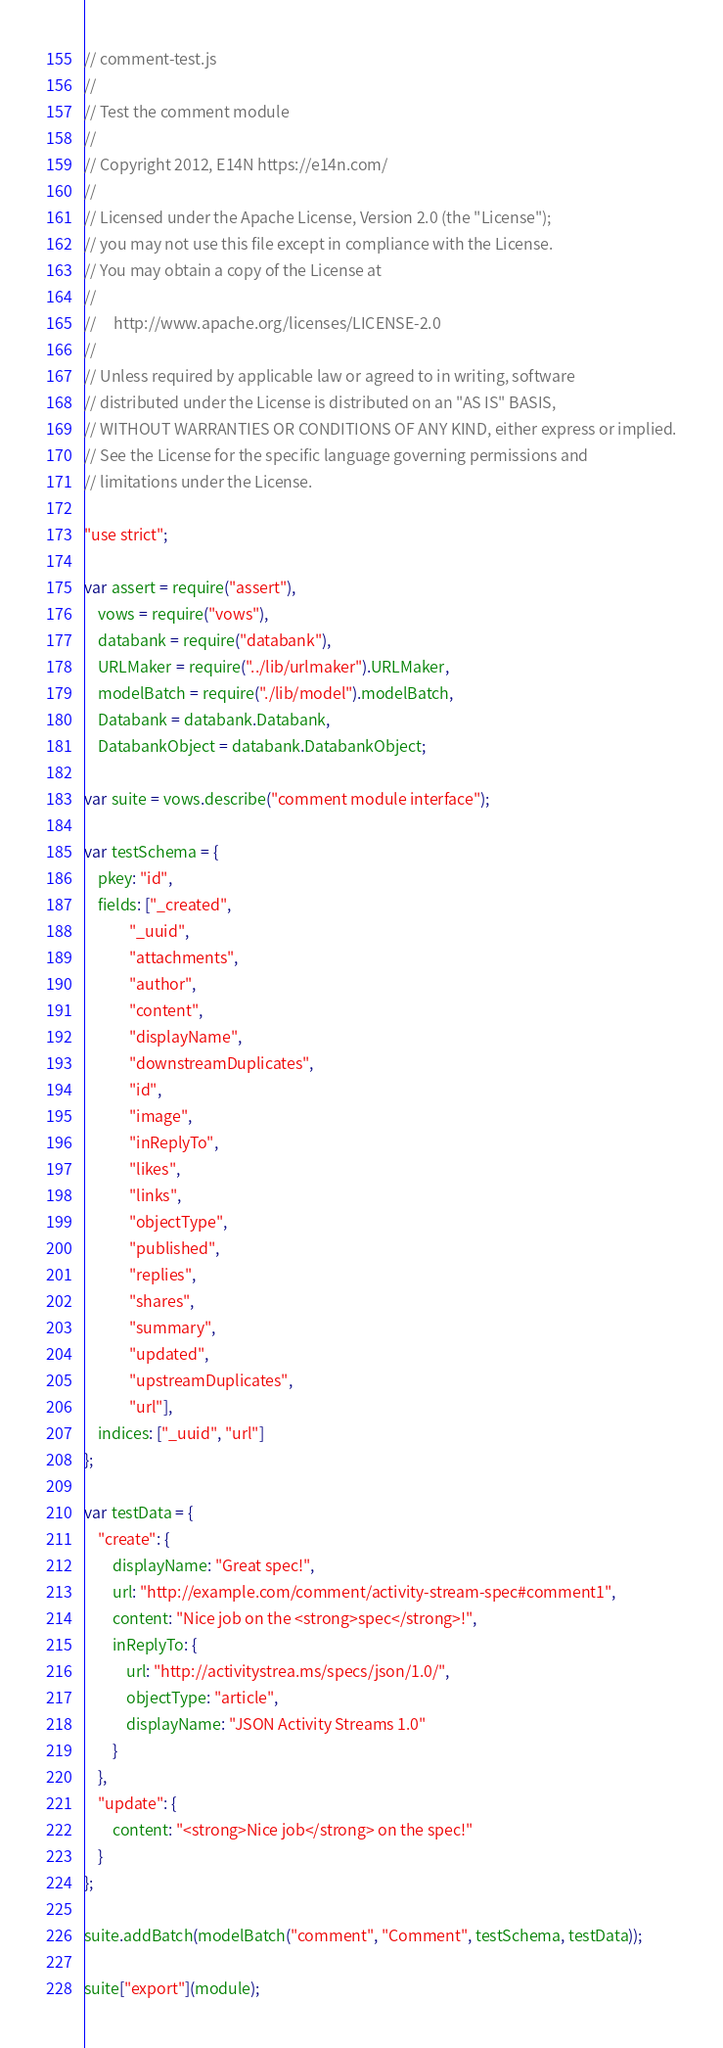<code> <loc_0><loc_0><loc_500><loc_500><_JavaScript_>// comment-test.js
//
// Test the comment module
//
// Copyright 2012, E14N https://e14n.com/
//
// Licensed under the Apache License, Version 2.0 (the "License");
// you may not use this file except in compliance with the License.
// You may obtain a copy of the License at
//
//     http://www.apache.org/licenses/LICENSE-2.0
//
// Unless required by applicable law or agreed to in writing, software
// distributed under the License is distributed on an "AS IS" BASIS,
// WITHOUT WARRANTIES OR CONDITIONS OF ANY KIND, either express or implied.
// See the License for the specific language governing permissions and
// limitations under the License.

"use strict";

var assert = require("assert"),
    vows = require("vows"),
    databank = require("databank"),
    URLMaker = require("../lib/urlmaker").URLMaker,
    modelBatch = require("./lib/model").modelBatch,
    Databank = databank.Databank,
    DatabankObject = databank.DatabankObject;

var suite = vows.describe("comment module interface");

var testSchema = {
    pkey: "id",
    fields: ["_created",
             "_uuid",
             "attachments",
             "author",
             "content",
             "displayName",
             "downstreamDuplicates",
             "id",
             "image",
             "inReplyTo",
             "likes",
             "links",
             "objectType",
             "published",
             "replies",
             "shares",
             "summary",
             "updated",
             "upstreamDuplicates",
             "url"],
    indices: ["_uuid", "url"]
};

var testData = {
    "create": {
        displayName: "Great spec!",
        url: "http://example.com/comment/activity-stream-spec#comment1",
        content: "Nice job on the <strong>spec</strong>!",
        inReplyTo: {
            url: "http://activitystrea.ms/specs/json/1.0/",
            objectType: "article",
            displayName: "JSON Activity Streams 1.0"
        }
    },
    "update": {
        content: "<strong>Nice job</strong> on the spec!"
    }
};

suite.addBatch(modelBatch("comment", "Comment", testSchema, testData));

suite["export"](module);
</code> 